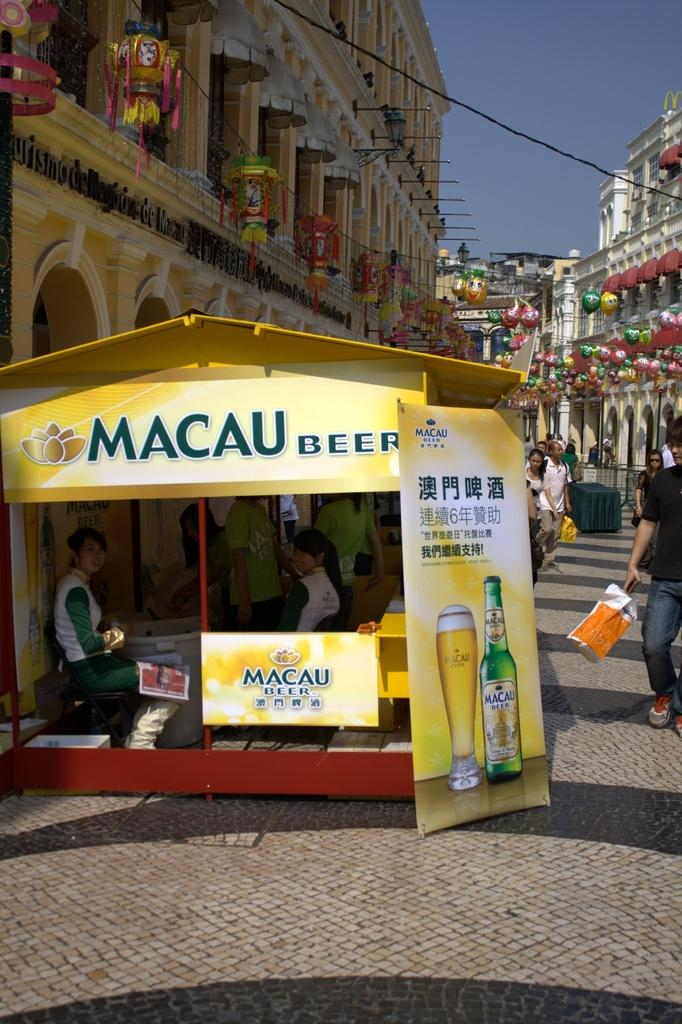<image>
Write a terse but informative summary of the picture. a Macau Beer location with people in it 